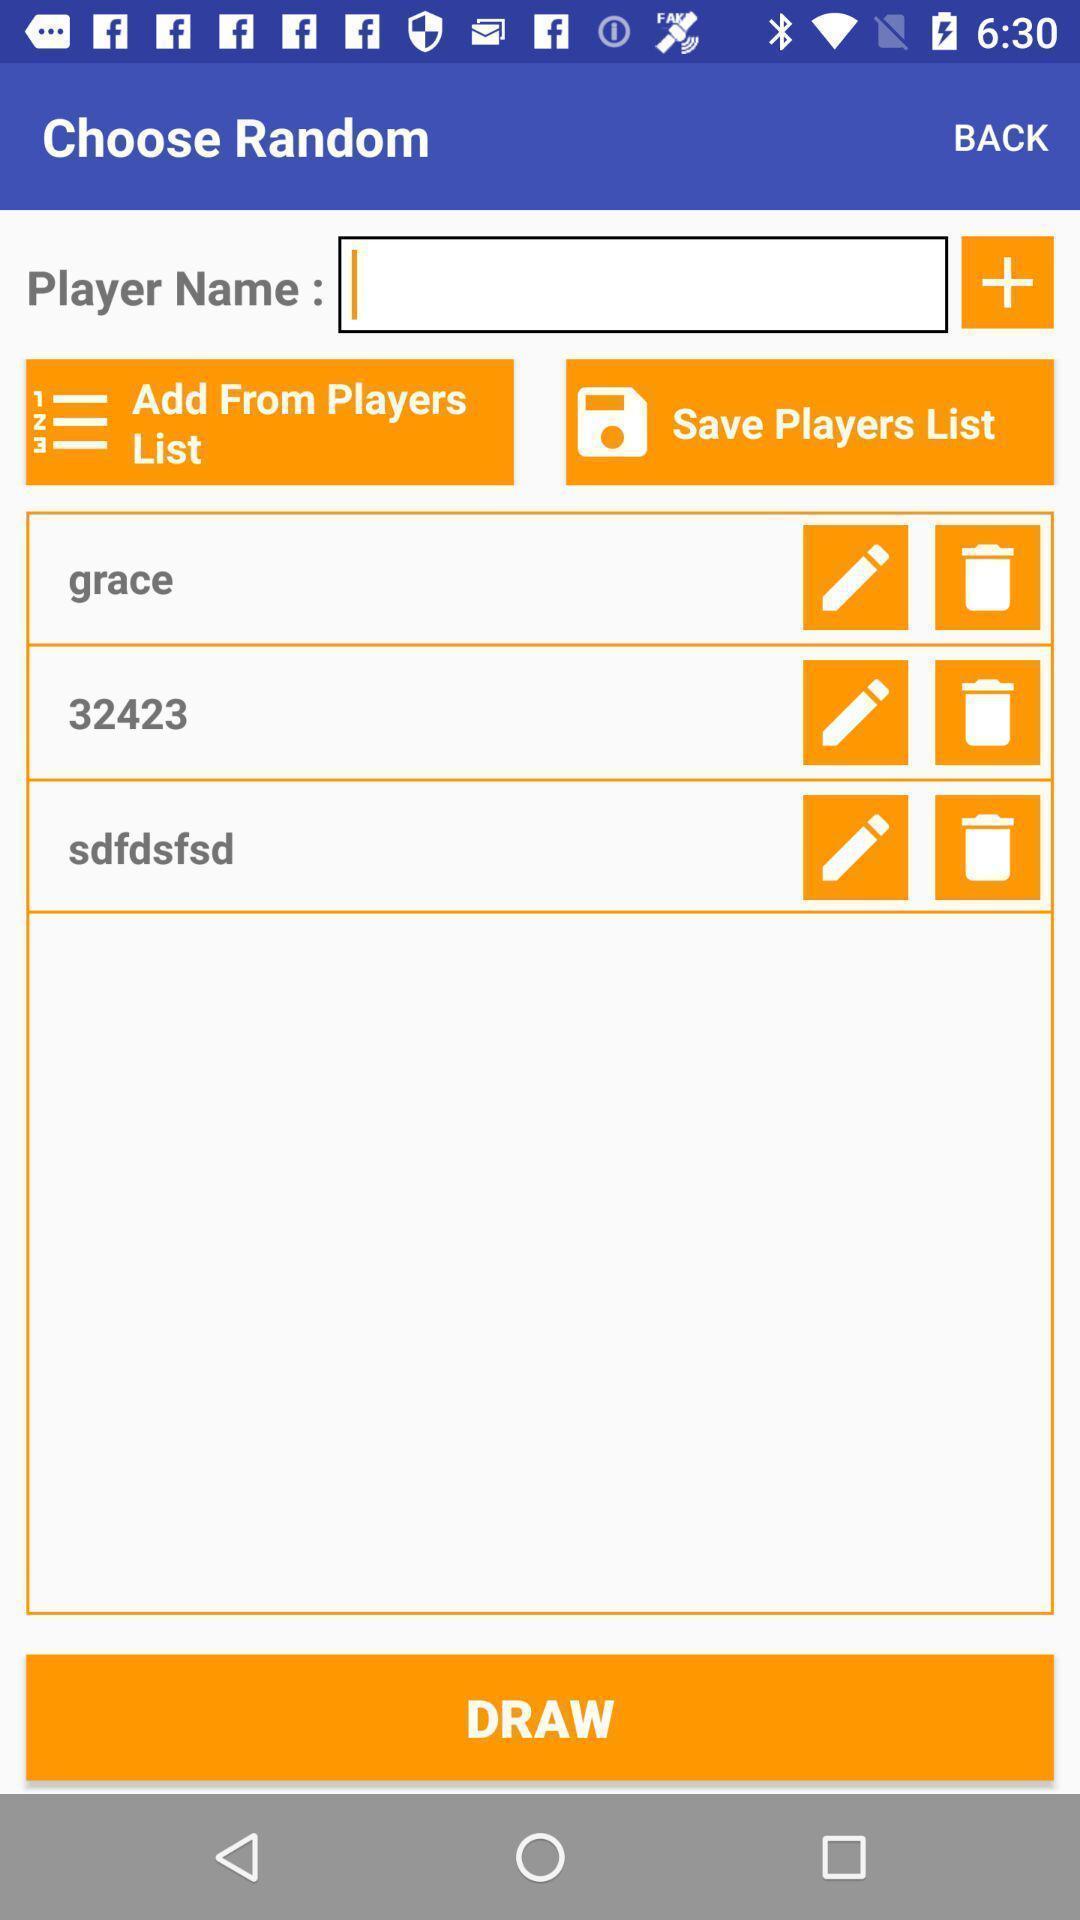Describe this image in words. Screen shows to enter player name. 